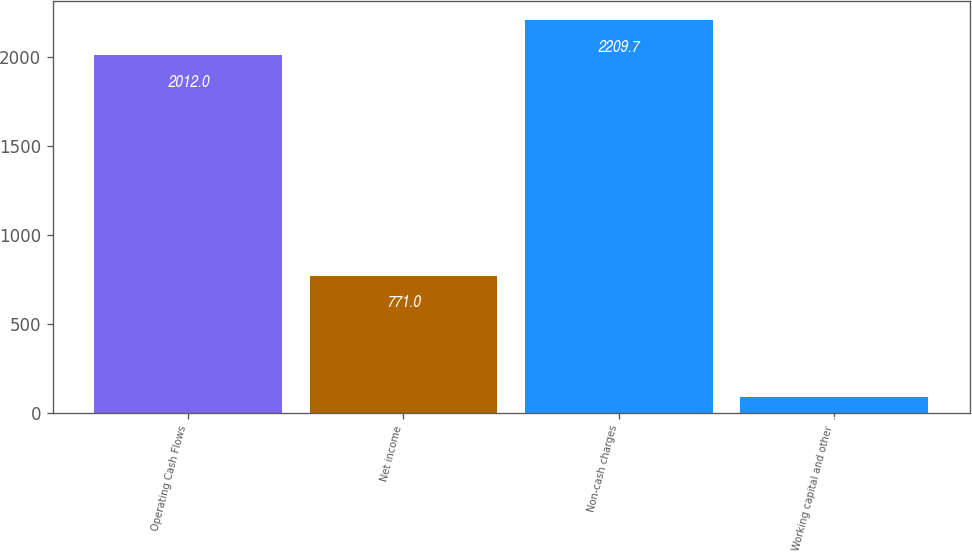Convert chart. <chart><loc_0><loc_0><loc_500><loc_500><bar_chart><fcel>Operating Cash Flows<fcel>Net income<fcel>Non-cash charges<fcel>Working capital and other<nl><fcel>2012<fcel>771<fcel>2209.7<fcel>86<nl></chart> 